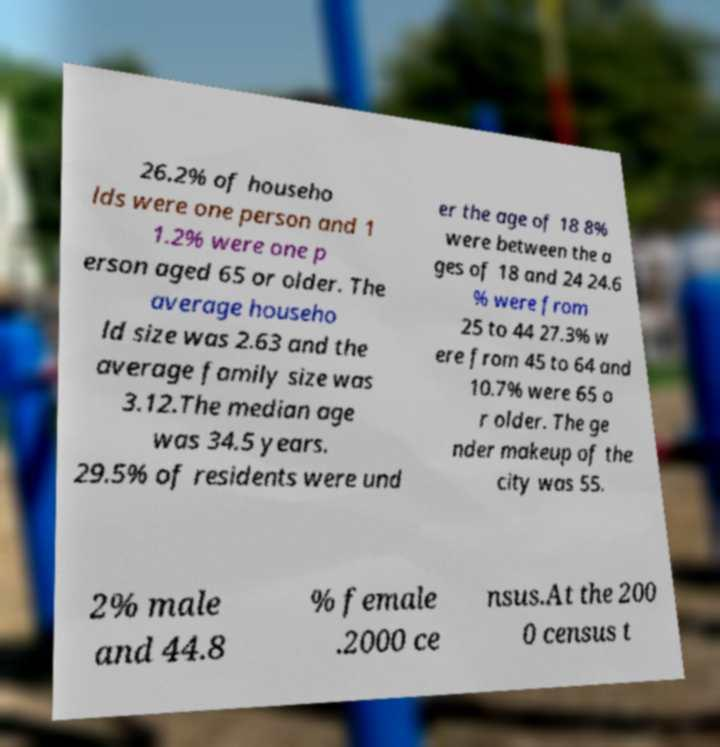For documentation purposes, I need the text within this image transcribed. Could you provide that? 26.2% of househo lds were one person and 1 1.2% were one p erson aged 65 or older. The average househo ld size was 2.63 and the average family size was 3.12.The median age was 34.5 years. 29.5% of residents were und er the age of 18 8% were between the a ges of 18 and 24 24.6 % were from 25 to 44 27.3% w ere from 45 to 64 and 10.7% were 65 o r older. The ge nder makeup of the city was 55. 2% male and 44.8 % female .2000 ce nsus.At the 200 0 census t 